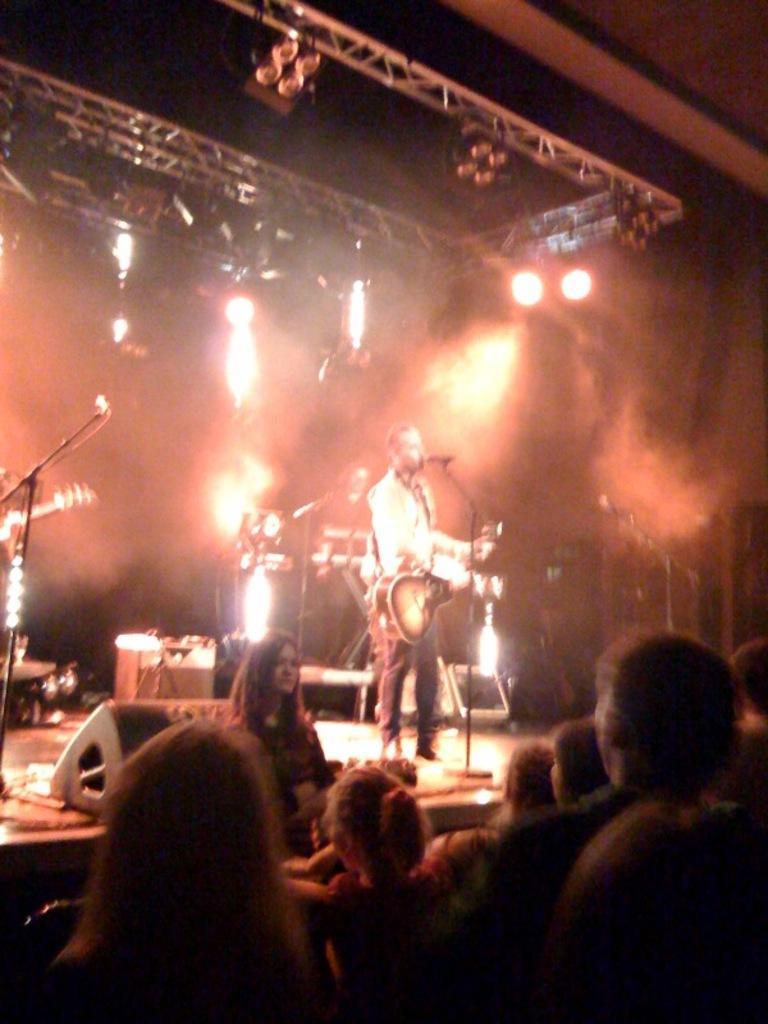Please provide a concise description of this image. In this image i can see few people standing down the stage, On the stage i can see a person wearing a white shirt and jeans standing and holding guitar in front of a microphone. In the background i can see a person standing in front of a musical instruments, a microphone, few lights, the dark sky and few metal rods. 